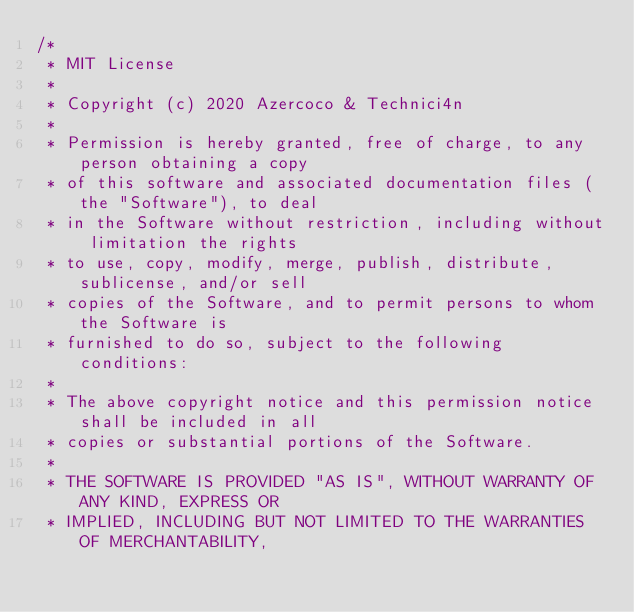<code> <loc_0><loc_0><loc_500><loc_500><_Java_>/*
 * MIT License
 *
 * Copyright (c) 2020 Azercoco & Technici4n
 *
 * Permission is hereby granted, free of charge, to any person obtaining a copy
 * of this software and associated documentation files (the "Software"), to deal
 * in the Software without restriction, including without limitation the rights
 * to use, copy, modify, merge, publish, distribute, sublicense, and/or sell
 * copies of the Software, and to permit persons to whom the Software is
 * furnished to do so, subject to the following conditions:
 *
 * The above copyright notice and this permission notice shall be included in all
 * copies or substantial portions of the Software.
 *
 * THE SOFTWARE IS PROVIDED "AS IS", WITHOUT WARRANTY OF ANY KIND, EXPRESS OR
 * IMPLIED, INCLUDING BUT NOT LIMITED TO THE WARRANTIES OF MERCHANTABILITY,</code> 